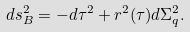<formula> <loc_0><loc_0><loc_500><loc_500>d s _ { B } ^ { 2 } = - d \tau ^ { 2 } + r ^ { 2 } ( \tau ) d \Sigma _ { q } ^ { 2 } .</formula> 